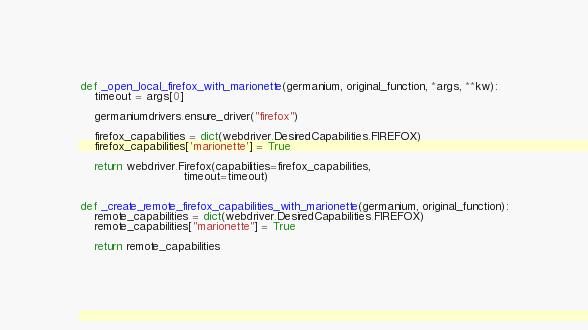<code> <loc_0><loc_0><loc_500><loc_500><_Python_>

def _open_local_firefox_with_marionette(germanium, original_function, *args, **kw):
    timeout = args[0]

    germaniumdrivers.ensure_driver("firefox")

    firefox_capabilities = dict(webdriver.DesiredCapabilities.FIREFOX)
    firefox_capabilities['marionette'] = True

    return webdriver.Firefox(capabilities=firefox_capabilities,
                             timeout=timeout)


def _create_remote_firefox_capabilities_with_marionette(germanium, original_function):
    remote_capabilities = dict(webdriver.DesiredCapabilities.FIREFOX)
    remote_capabilities["marionette"] = True

    return remote_capabilities
</code> 